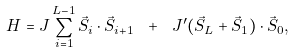<formula> <loc_0><loc_0><loc_500><loc_500>H = J \sum _ { i = 1 } ^ { L - 1 } \vec { S } _ { i } \cdot \vec { S } _ { i + 1 } \ + \ J ^ { \prime } ( \vec { S } _ { L } + \vec { S } _ { 1 } ) \cdot \vec { S } _ { 0 } ,</formula> 